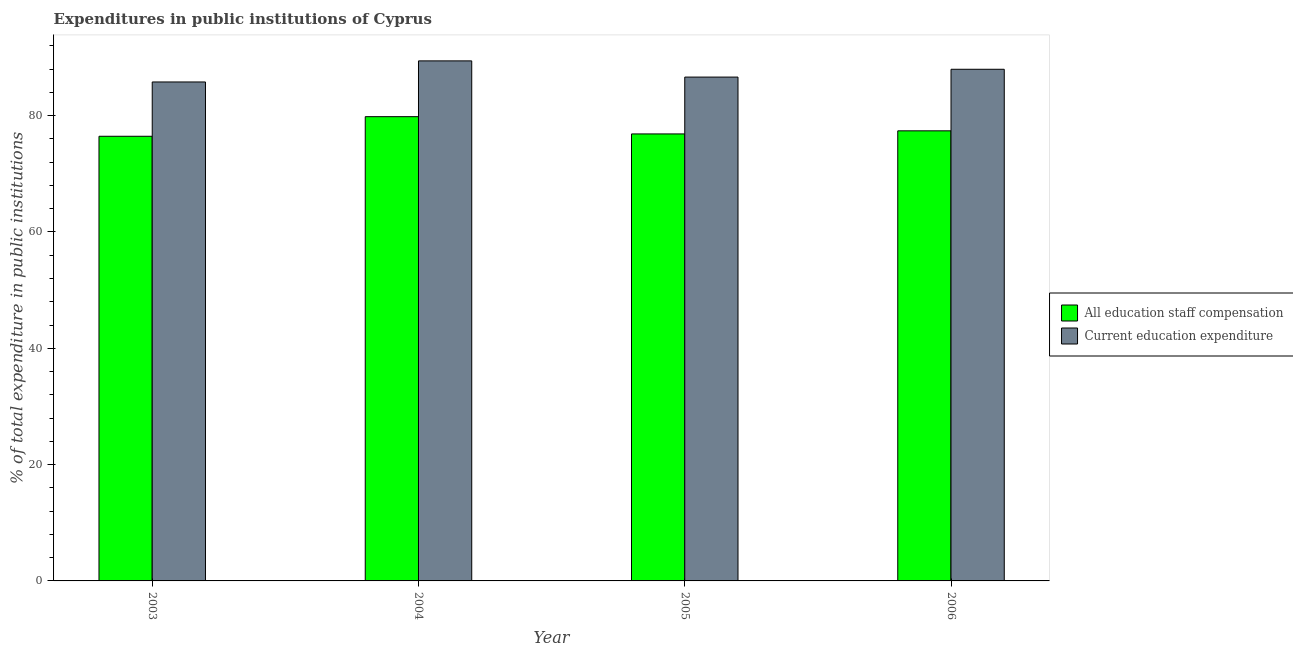How many bars are there on the 2nd tick from the left?
Offer a very short reply. 2. What is the label of the 2nd group of bars from the left?
Offer a terse response. 2004. What is the expenditure in staff compensation in 2006?
Your answer should be very brief. 77.38. Across all years, what is the maximum expenditure in education?
Your response must be concise. 89.41. Across all years, what is the minimum expenditure in education?
Your response must be concise. 85.78. In which year was the expenditure in staff compensation maximum?
Keep it short and to the point. 2004. What is the total expenditure in staff compensation in the graph?
Your response must be concise. 310.5. What is the difference between the expenditure in staff compensation in 2003 and that in 2005?
Your answer should be compact. -0.4. What is the difference between the expenditure in education in 2005 and the expenditure in staff compensation in 2004?
Keep it short and to the point. -2.79. What is the average expenditure in education per year?
Your response must be concise. 87.45. In how many years, is the expenditure in staff compensation greater than 68 %?
Offer a terse response. 4. What is the ratio of the expenditure in staff compensation in 2003 to that in 2006?
Offer a very short reply. 0.99. Is the expenditure in staff compensation in 2005 less than that in 2006?
Your response must be concise. Yes. Is the difference between the expenditure in education in 2003 and 2004 greater than the difference between the expenditure in staff compensation in 2003 and 2004?
Make the answer very short. No. What is the difference between the highest and the second highest expenditure in staff compensation?
Offer a terse response. 2.44. What is the difference between the highest and the lowest expenditure in staff compensation?
Your answer should be compact. 3.37. In how many years, is the expenditure in education greater than the average expenditure in education taken over all years?
Your answer should be very brief. 2. What does the 1st bar from the left in 2004 represents?
Ensure brevity in your answer.  All education staff compensation. What does the 2nd bar from the right in 2006 represents?
Give a very brief answer. All education staff compensation. Are all the bars in the graph horizontal?
Provide a short and direct response. No. How many years are there in the graph?
Make the answer very short. 4. Does the graph contain grids?
Your answer should be very brief. No. What is the title of the graph?
Your answer should be compact. Expenditures in public institutions of Cyprus. What is the label or title of the X-axis?
Ensure brevity in your answer.  Year. What is the label or title of the Y-axis?
Your answer should be compact. % of total expenditure in public institutions. What is the % of total expenditure in public institutions of All education staff compensation in 2003?
Your answer should be compact. 76.45. What is the % of total expenditure in public institutions of Current education expenditure in 2003?
Provide a succinct answer. 85.78. What is the % of total expenditure in public institutions in All education staff compensation in 2004?
Your answer should be very brief. 79.82. What is the % of total expenditure in public institutions of Current education expenditure in 2004?
Offer a very short reply. 89.41. What is the % of total expenditure in public institutions in All education staff compensation in 2005?
Ensure brevity in your answer.  76.85. What is the % of total expenditure in public institutions of Current education expenditure in 2005?
Provide a short and direct response. 86.62. What is the % of total expenditure in public institutions of All education staff compensation in 2006?
Provide a succinct answer. 77.38. What is the % of total expenditure in public institutions in Current education expenditure in 2006?
Provide a succinct answer. 87.97. Across all years, what is the maximum % of total expenditure in public institutions of All education staff compensation?
Your answer should be very brief. 79.82. Across all years, what is the maximum % of total expenditure in public institutions of Current education expenditure?
Give a very brief answer. 89.41. Across all years, what is the minimum % of total expenditure in public institutions of All education staff compensation?
Make the answer very short. 76.45. Across all years, what is the minimum % of total expenditure in public institutions of Current education expenditure?
Make the answer very short. 85.78. What is the total % of total expenditure in public institutions in All education staff compensation in the graph?
Provide a succinct answer. 310.5. What is the total % of total expenditure in public institutions of Current education expenditure in the graph?
Give a very brief answer. 349.79. What is the difference between the % of total expenditure in public institutions of All education staff compensation in 2003 and that in 2004?
Offer a terse response. -3.37. What is the difference between the % of total expenditure in public institutions in Current education expenditure in 2003 and that in 2004?
Make the answer very short. -3.63. What is the difference between the % of total expenditure in public institutions in All education staff compensation in 2003 and that in 2005?
Provide a short and direct response. -0.4. What is the difference between the % of total expenditure in public institutions in Current education expenditure in 2003 and that in 2005?
Offer a terse response. -0.84. What is the difference between the % of total expenditure in public institutions of All education staff compensation in 2003 and that in 2006?
Offer a terse response. -0.93. What is the difference between the % of total expenditure in public institutions of Current education expenditure in 2003 and that in 2006?
Give a very brief answer. -2.18. What is the difference between the % of total expenditure in public institutions of All education staff compensation in 2004 and that in 2005?
Your answer should be compact. 2.97. What is the difference between the % of total expenditure in public institutions of Current education expenditure in 2004 and that in 2005?
Make the answer very short. 2.79. What is the difference between the % of total expenditure in public institutions of All education staff compensation in 2004 and that in 2006?
Keep it short and to the point. 2.44. What is the difference between the % of total expenditure in public institutions of Current education expenditure in 2004 and that in 2006?
Your response must be concise. 1.44. What is the difference between the % of total expenditure in public institutions of All education staff compensation in 2005 and that in 2006?
Provide a short and direct response. -0.53. What is the difference between the % of total expenditure in public institutions of Current education expenditure in 2005 and that in 2006?
Provide a short and direct response. -1.34. What is the difference between the % of total expenditure in public institutions in All education staff compensation in 2003 and the % of total expenditure in public institutions in Current education expenditure in 2004?
Keep it short and to the point. -12.96. What is the difference between the % of total expenditure in public institutions of All education staff compensation in 2003 and the % of total expenditure in public institutions of Current education expenditure in 2005?
Offer a very short reply. -10.18. What is the difference between the % of total expenditure in public institutions of All education staff compensation in 2003 and the % of total expenditure in public institutions of Current education expenditure in 2006?
Provide a succinct answer. -11.52. What is the difference between the % of total expenditure in public institutions of All education staff compensation in 2004 and the % of total expenditure in public institutions of Current education expenditure in 2005?
Offer a terse response. -6.81. What is the difference between the % of total expenditure in public institutions of All education staff compensation in 2004 and the % of total expenditure in public institutions of Current education expenditure in 2006?
Provide a short and direct response. -8.15. What is the difference between the % of total expenditure in public institutions of All education staff compensation in 2005 and the % of total expenditure in public institutions of Current education expenditure in 2006?
Give a very brief answer. -11.12. What is the average % of total expenditure in public institutions of All education staff compensation per year?
Offer a very short reply. 77.63. What is the average % of total expenditure in public institutions of Current education expenditure per year?
Make the answer very short. 87.45. In the year 2003, what is the difference between the % of total expenditure in public institutions of All education staff compensation and % of total expenditure in public institutions of Current education expenditure?
Offer a very short reply. -9.34. In the year 2004, what is the difference between the % of total expenditure in public institutions in All education staff compensation and % of total expenditure in public institutions in Current education expenditure?
Offer a terse response. -9.59. In the year 2005, what is the difference between the % of total expenditure in public institutions in All education staff compensation and % of total expenditure in public institutions in Current education expenditure?
Give a very brief answer. -9.77. In the year 2006, what is the difference between the % of total expenditure in public institutions in All education staff compensation and % of total expenditure in public institutions in Current education expenditure?
Offer a very short reply. -10.59. What is the ratio of the % of total expenditure in public institutions in All education staff compensation in 2003 to that in 2004?
Provide a succinct answer. 0.96. What is the ratio of the % of total expenditure in public institutions in Current education expenditure in 2003 to that in 2004?
Your answer should be very brief. 0.96. What is the ratio of the % of total expenditure in public institutions in All education staff compensation in 2003 to that in 2005?
Make the answer very short. 0.99. What is the ratio of the % of total expenditure in public institutions in Current education expenditure in 2003 to that in 2005?
Offer a very short reply. 0.99. What is the ratio of the % of total expenditure in public institutions in All education staff compensation in 2003 to that in 2006?
Provide a short and direct response. 0.99. What is the ratio of the % of total expenditure in public institutions in Current education expenditure in 2003 to that in 2006?
Your response must be concise. 0.98. What is the ratio of the % of total expenditure in public institutions of All education staff compensation in 2004 to that in 2005?
Your answer should be compact. 1.04. What is the ratio of the % of total expenditure in public institutions of Current education expenditure in 2004 to that in 2005?
Make the answer very short. 1.03. What is the ratio of the % of total expenditure in public institutions in All education staff compensation in 2004 to that in 2006?
Ensure brevity in your answer.  1.03. What is the ratio of the % of total expenditure in public institutions in Current education expenditure in 2004 to that in 2006?
Your answer should be very brief. 1.02. What is the ratio of the % of total expenditure in public institutions in All education staff compensation in 2005 to that in 2006?
Your answer should be very brief. 0.99. What is the ratio of the % of total expenditure in public institutions in Current education expenditure in 2005 to that in 2006?
Make the answer very short. 0.98. What is the difference between the highest and the second highest % of total expenditure in public institutions in All education staff compensation?
Offer a terse response. 2.44. What is the difference between the highest and the second highest % of total expenditure in public institutions of Current education expenditure?
Provide a short and direct response. 1.44. What is the difference between the highest and the lowest % of total expenditure in public institutions in All education staff compensation?
Provide a short and direct response. 3.37. What is the difference between the highest and the lowest % of total expenditure in public institutions of Current education expenditure?
Keep it short and to the point. 3.63. 